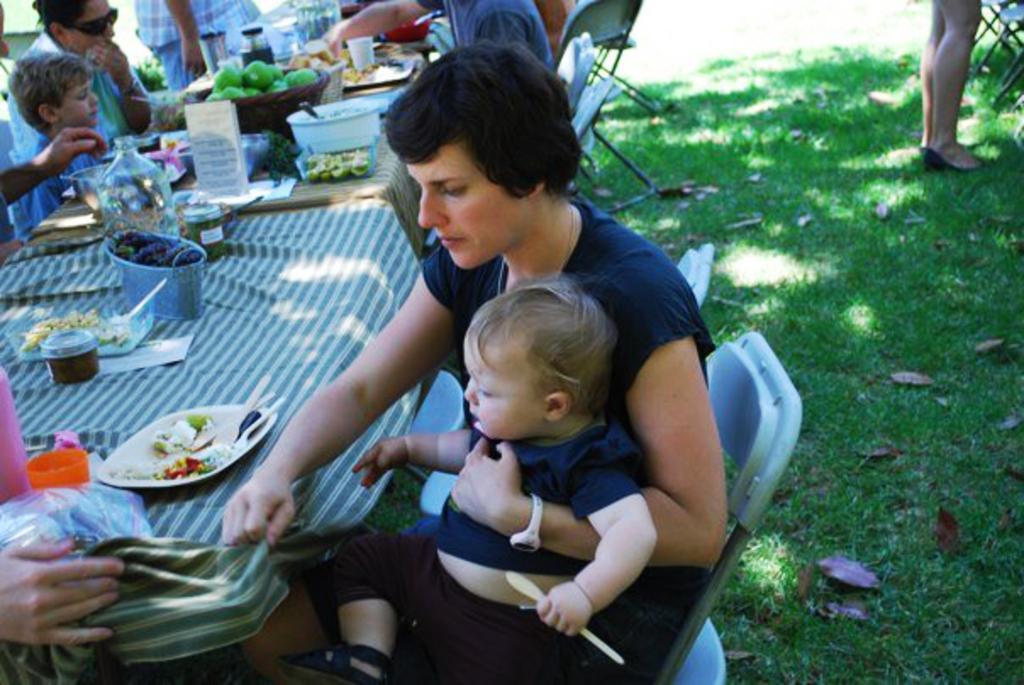Can you describe this image briefly? In this image i can see group of persons sitting around the table and having their food there are some food items on top of the table and at the right side of the image there is a person standing. 